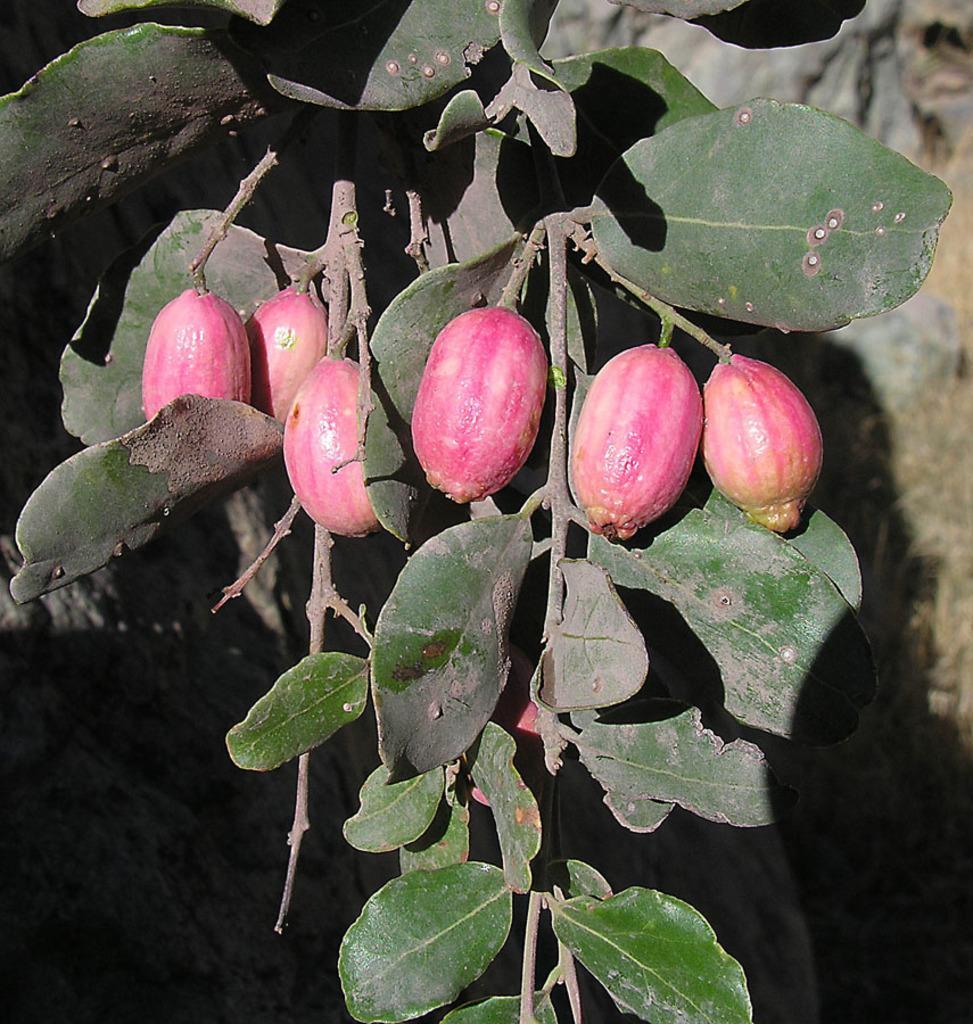Describe this image in one or two sentences. This picture shows a tree branch with some fruits to it. 